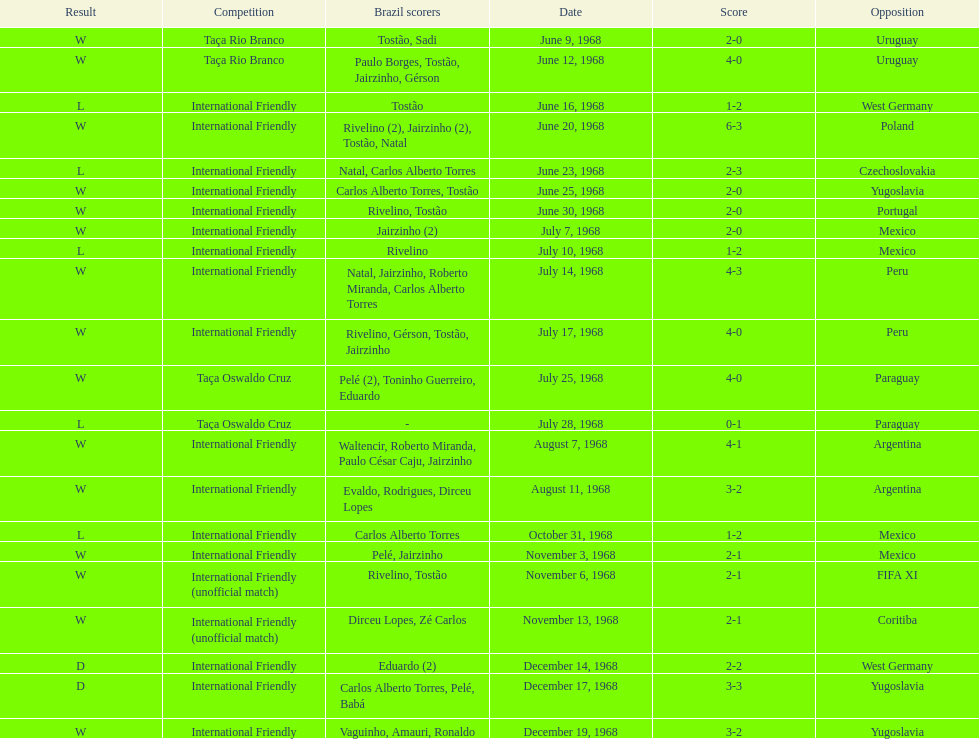What is the top score ever scored by the brazil national team? 6. 